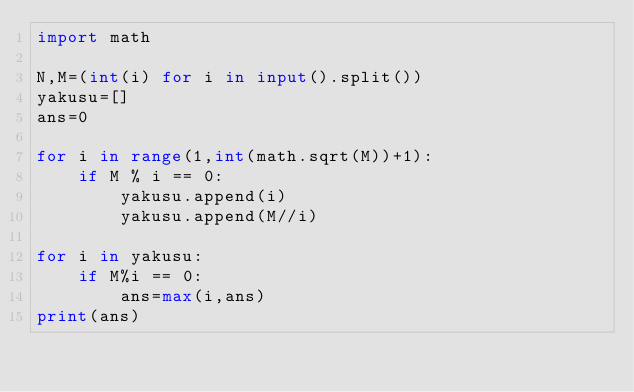<code> <loc_0><loc_0><loc_500><loc_500><_Python_>import math

N,M=(int(i) for i in input().split())
yakusu=[]
ans=0

for i in range(1,int(math.sqrt(M))+1):
    if M % i == 0:
        yakusu.append(i)
        yakusu.append(M//i)

for i in yakusu:
	if M%i == 0:
		ans=max(i,ans)
print(ans)</code> 